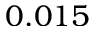<formula> <loc_0><loc_0><loc_500><loc_500>0 . 0 1 5</formula> 